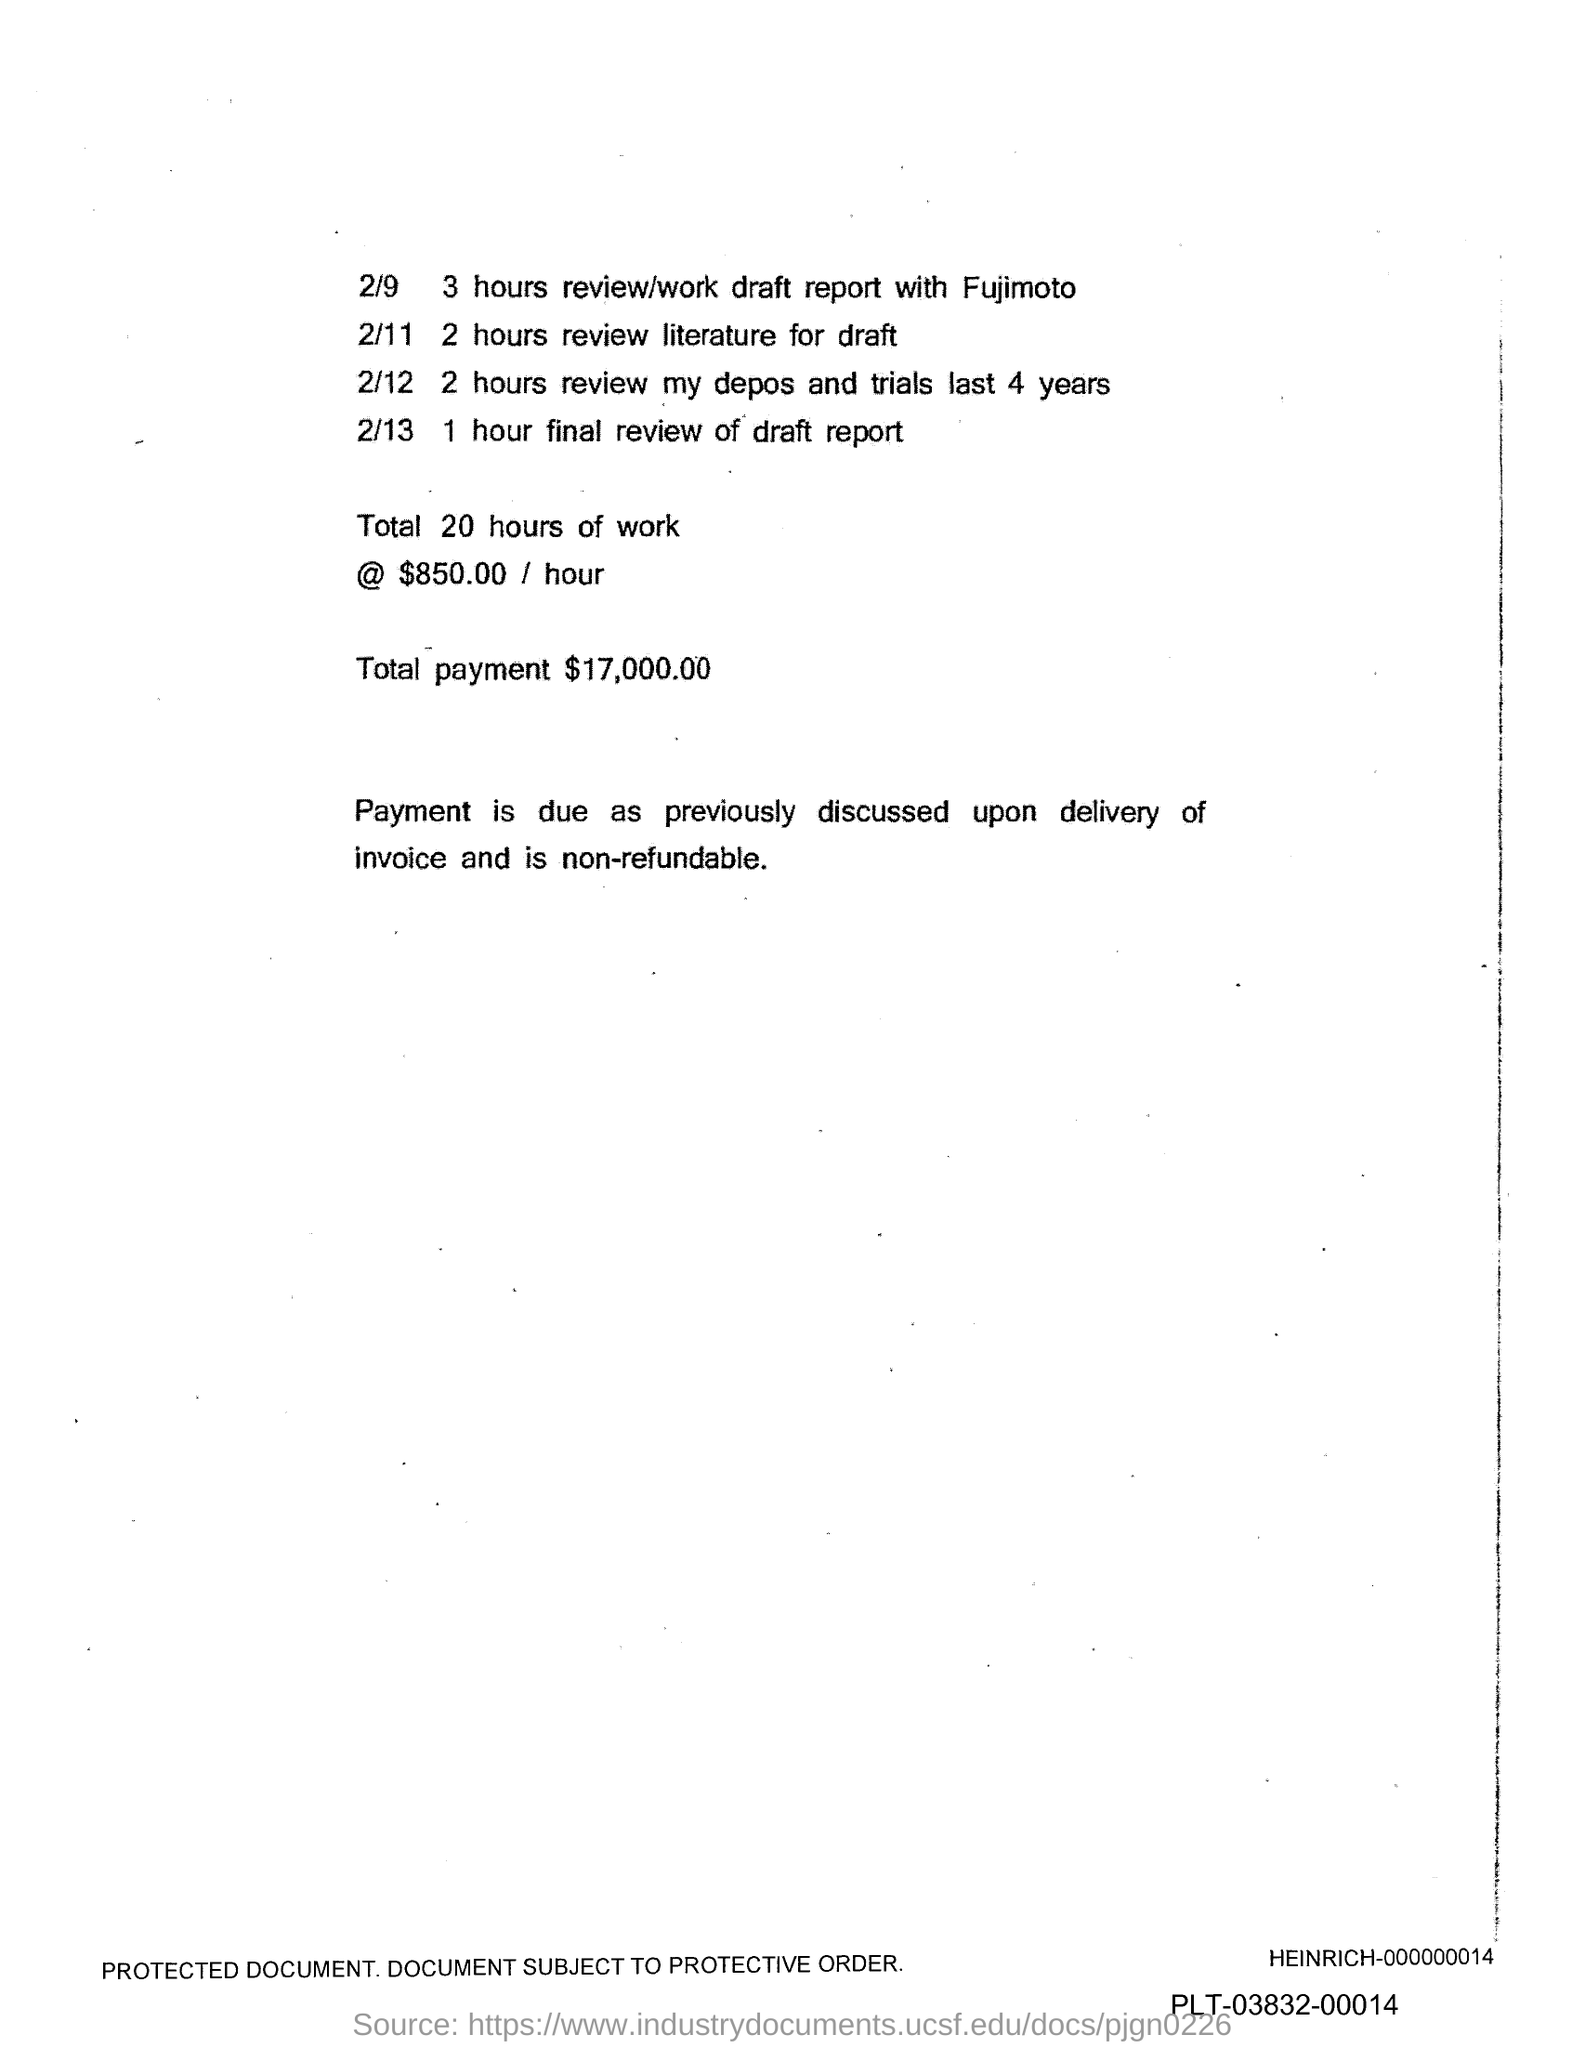What is the total payment?
Make the answer very short. $ 17,000.00. 